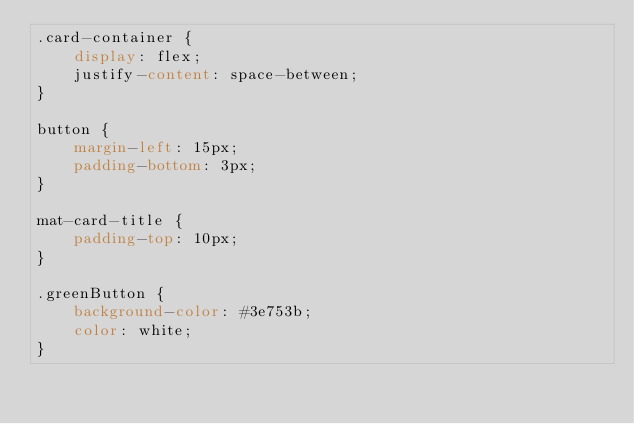<code> <loc_0><loc_0><loc_500><loc_500><_CSS_>.card-container {
    display: flex;
    justify-content: space-between;
}

button {
    margin-left: 15px;
    padding-bottom: 3px;
}

mat-card-title {
    padding-top: 10px;
}

.greenButton {
    background-color: #3e753b;
    color: white;
}</code> 